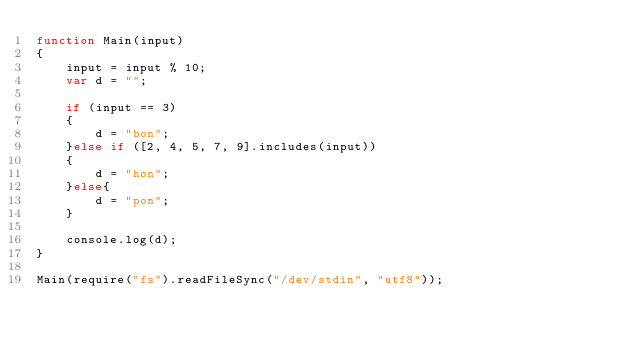Convert code to text. <code><loc_0><loc_0><loc_500><loc_500><_JavaScript_>function Main(input)
{
	input = input % 10;
	var d = "";

	if (input == 3)
	{
		d = "bon";
	}else if ([2, 4, 5, 7, 9].includes(input))
	{
		d = "hon";
	}else{
		d = "pon";
	}

	console.log(d);
}

Main(require("fs").readFileSync("/dev/stdin", "utf8"));</code> 